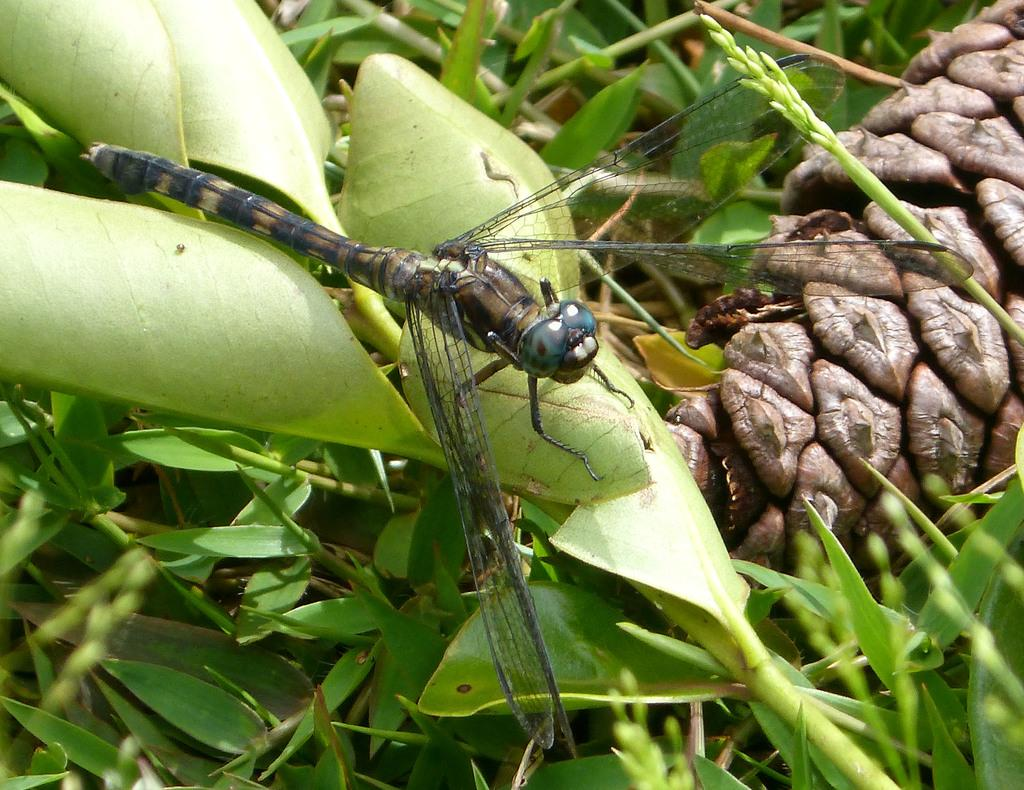What type of creature can be seen in the image? There is an insect on leaves in the image. What can be seen in the background of the image? There are plants in the background of the image. What type of book is the insect reading in the image? There is no book present in the image; it features an insect on leaves. What shape is the insect in the image? The insect's shape cannot be determined from the image alone, as it is a photograph and not a drawing or illustration. 